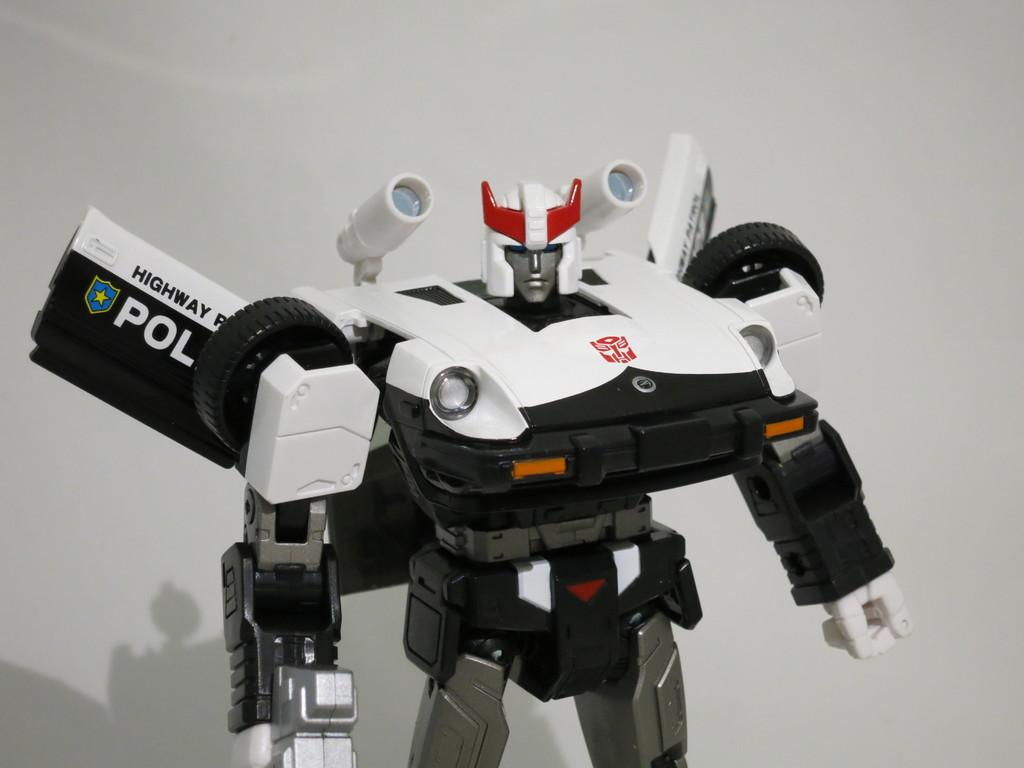<image>
Render a clear and concise summary of the photo. A Transformer figure with HIGHWAY POL on the car door. 